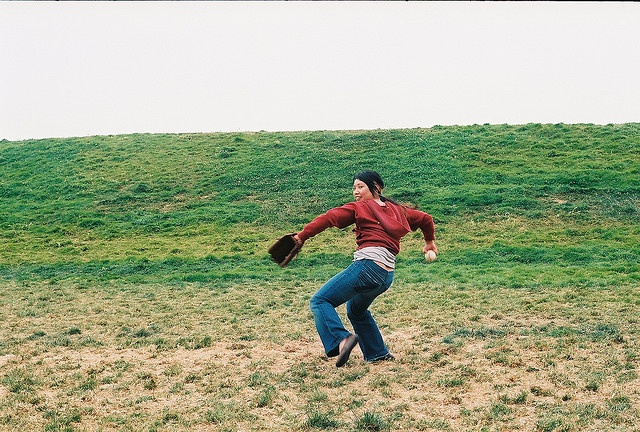Describe the objects in this image and their specific colors. I can see people in lightgray, black, blue, maroon, and brown tones, baseball glove in lightgray, black, maroon, and gray tones, and sports ball in lightgray, beige, and tan tones in this image. 